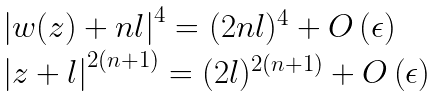<formula> <loc_0><loc_0><loc_500><loc_500>\begin{array} { l } \left | w ( z ) + n l \right | ^ { 4 } = ( 2 n l ) ^ { 4 } + O \left ( \epsilon \right ) \\ \left | z + l \right | ^ { 2 ( n + 1 ) } = ( 2 l ) ^ { 2 ( n + 1 ) } + O \left ( \epsilon \right ) \end{array}</formula> 